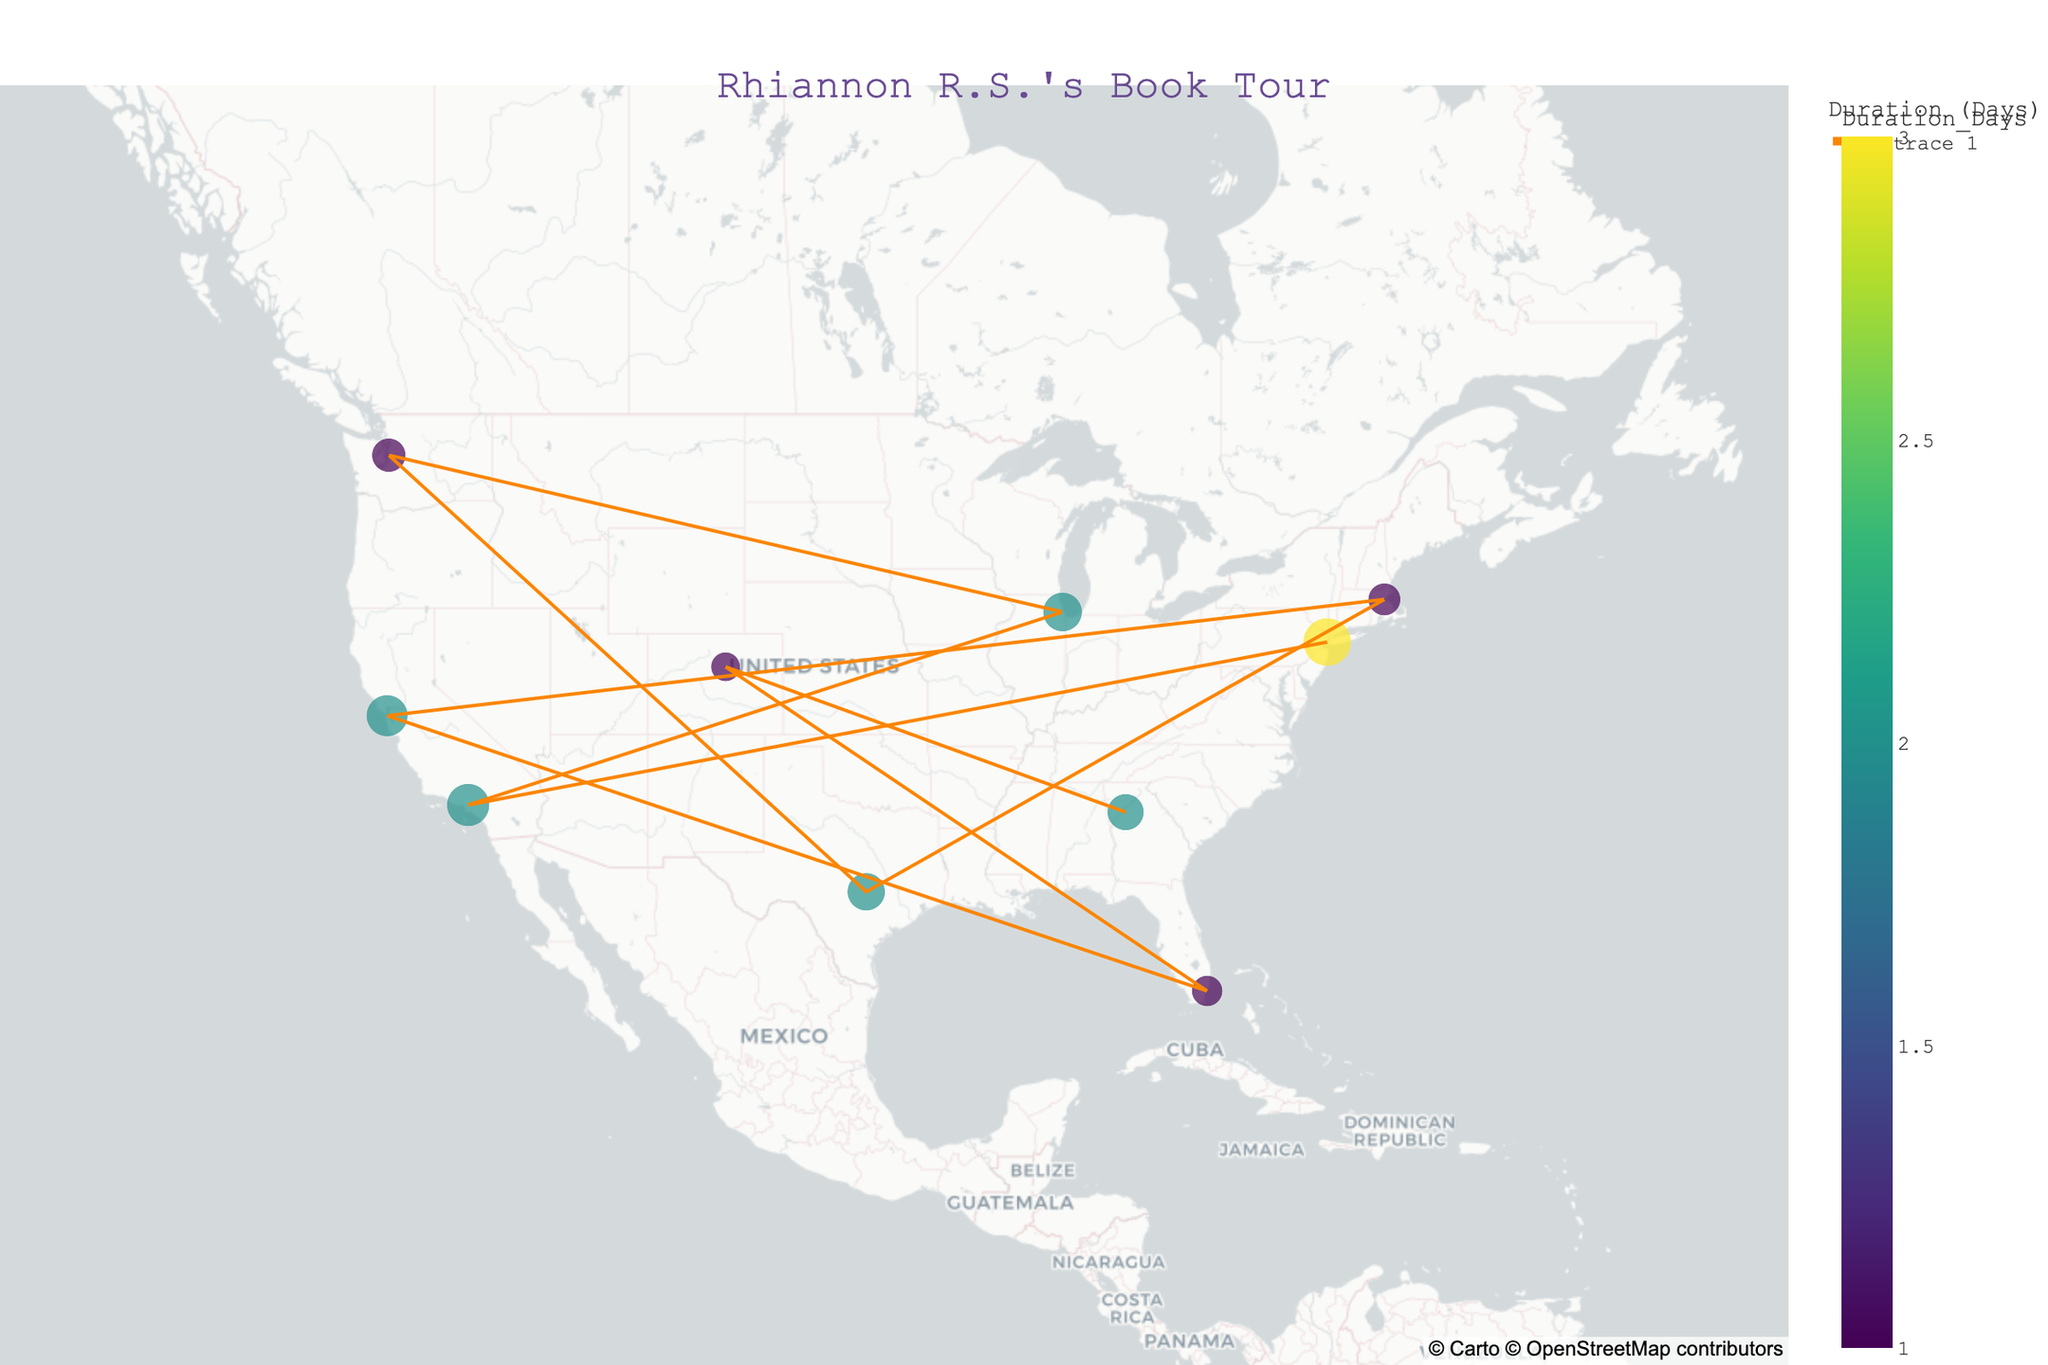Which city did Rhiannon R.S. spend the longest time on her book tour? To answer the question, look for the city with the highest value in the "Duration_Days" color scale. New York City has the largest circle, indicating she spent 3 days there.
Answer: New York City How many cities did Rhiannon R.S. visit in total during her book tour? Count the number of distinct circles on the map. There are 10 circles representing 10 different cities.
Answer: 10 Which city had the highest attendance? Check the size of the circles, where the largest circle represents the highest attendance. New York City has the largest circle with an attendance of 1200.
Answer: New York City What is the total duration of the book tour in days? Sum up the "Duration_Days" values: 3 (NY) + 2 (LA) + 2 (Chicago) + 1 (Seattle) + 2 (Austin) + 1 (Boston) + 2 (SF) + 1 (Miami) + 1 (Denver) + 2 (Atlanta) = 17 days.
Answer: 17 Which city in California had a higher attendance, Los Angeles or San Francisco? Compare the sizes of the circles for Los Angeles (950) and San Francisco (900). Los Angeles has a higher attendance.
Answer: Los Angeles What was the shortest stop on the tour in terms of duration? Identify cities with the smallest value in the "Duration_Days" color scale. Seattle, Boston, Miami, and Denver each have a duration of 1 day.
Answer: Seattle, Boston, Miami, Denver Which state had the most cities visited during the book tour? Identify the states and count the number of cities visited in each state. California has two cities: Los Angeles and San Francisco.
Answer: California What was the average attendance per city on the tour? Sum the attendance figures for all cities and divide by the number of cities: (1200+950+800+600+750+550+900+500+450+700)/10 = 740.
Answer: 740 